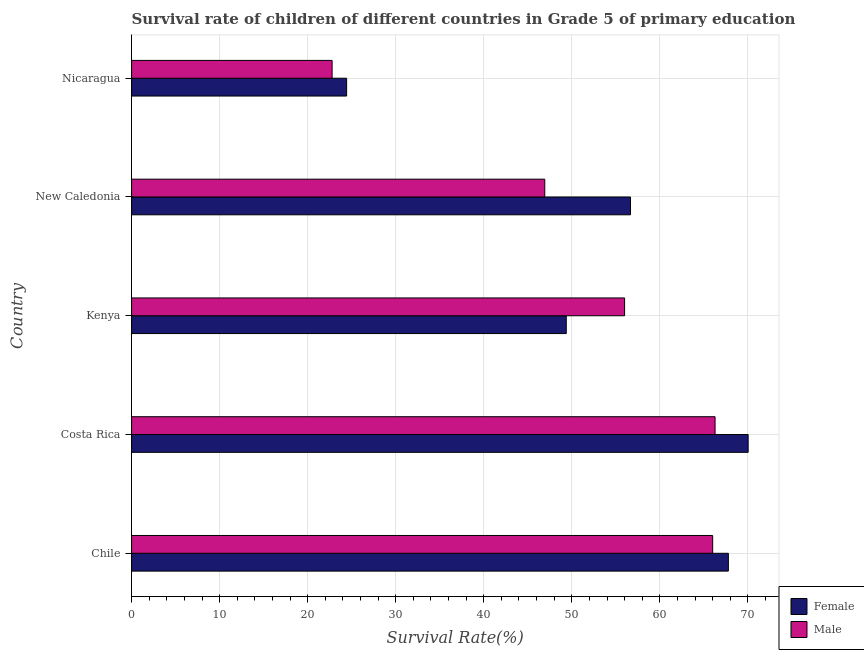How many bars are there on the 2nd tick from the top?
Offer a very short reply. 2. How many bars are there on the 3rd tick from the bottom?
Your answer should be very brief. 2. What is the label of the 1st group of bars from the top?
Your answer should be very brief. Nicaragua. In how many cases, is the number of bars for a given country not equal to the number of legend labels?
Offer a very short reply. 0. What is the survival rate of male students in primary education in Chile?
Make the answer very short. 66. Across all countries, what is the maximum survival rate of female students in primary education?
Make the answer very short. 70.03. Across all countries, what is the minimum survival rate of male students in primary education?
Ensure brevity in your answer.  22.78. In which country was the survival rate of female students in primary education minimum?
Keep it short and to the point. Nicaragua. What is the total survival rate of female students in primary education in the graph?
Provide a short and direct response. 268.29. What is the difference between the survival rate of male students in primary education in Costa Rica and that in New Caledonia?
Your answer should be very brief. 19.34. What is the difference between the survival rate of male students in primary education in Costa Rica and the survival rate of female students in primary education in Nicaragua?
Provide a short and direct response. 41.85. What is the average survival rate of male students in primary education per country?
Make the answer very short. 51.6. What is the difference between the survival rate of male students in primary education and survival rate of female students in primary education in Nicaragua?
Offer a terse response. -1.65. In how many countries, is the survival rate of female students in primary education greater than 66 %?
Ensure brevity in your answer.  2. What is the ratio of the survival rate of male students in primary education in Costa Rica to that in New Caledonia?
Provide a succinct answer. 1.41. Is the survival rate of female students in primary education in Costa Rica less than that in Nicaragua?
Provide a short and direct response. No. Is the difference between the survival rate of male students in primary education in Kenya and New Caledonia greater than the difference between the survival rate of female students in primary education in Kenya and New Caledonia?
Offer a terse response. Yes. What is the difference between the highest and the second highest survival rate of male students in primary education?
Provide a short and direct response. 0.27. What is the difference between the highest and the lowest survival rate of female students in primary education?
Your answer should be compact. 45.61. In how many countries, is the survival rate of female students in primary education greater than the average survival rate of female students in primary education taken over all countries?
Your answer should be very brief. 3. Is the sum of the survival rate of male students in primary education in Kenya and Nicaragua greater than the maximum survival rate of female students in primary education across all countries?
Ensure brevity in your answer.  Yes. What does the 1st bar from the bottom in Nicaragua represents?
Offer a terse response. Female. Are all the bars in the graph horizontal?
Keep it short and to the point. Yes. How many countries are there in the graph?
Ensure brevity in your answer.  5. What is the difference between two consecutive major ticks on the X-axis?
Give a very brief answer. 10. Does the graph contain any zero values?
Your answer should be compact. No. Does the graph contain grids?
Ensure brevity in your answer.  Yes. How many legend labels are there?
Ensure brevity in your answer.  2. How are the legend labels stacked?
Your answer should be very brief. Vertical. What is the title of the graph?
Provide a succinct answer. Survival rate of children of different countries in Grade 5 of primary education. Does "Passenger Transport Items" appear as one of the legend labels in the graph?
Offer a very short reply. No. What is the label or title of the X-axis?
Give a very brief answer. Survival Rate(%). What is the Survival Rate(%) in Female in Chile?
Your answer should be compact. 67.79. What is the Survival Rate(%) in Male in Chile?
Offer a very short reply. 66. What is the Survival Rate(%) of Female in Costa Rica?
Provide a succinct answer. 70.03. What is the Survival Rate(%) in Male in Costa Rica?
Ensure brevity in your answer.  66.27. What is the Survival Rate(%) in Female in Kenya?
Your response must be concise. 49.37. What is the Survival Rate(%) of Male in Kenya?
Your answer should be compact. 56. What is the Survival Rate(%) in Female in New Caledonia?
Make the answer very short. 56.67. What is the Survival Rate(%) of Male in New Caledonia?
Make the answer very short. 46.93. What is the Survival Rate(%) of Female in Nicaragua?
Ensure brevity in your answer.  24.43. What is the Survival Rate(%) in Male in Nicaragua?
Give a very brief answer. 22.78. Across all countries, what is the maximum Survival Rate(%) in Female?
Make the answer very short. 70.03. Across all countries, what is the maximum Survival Rate(%) in Male?
Offer a very short reply. 66.27. Across all countries, what is the minimum Survival Rate(%) in Female?
Your answer should be compact. 24.43. Across all countries, what is the minimum Survival Rate(%) in Male?
Your answer should be compact. 22.78. What is the total Survival Rate(%) of Female in the graph?
Provide a short and direct response. 268.29. What is the total Survival Rate(%) of Male in the graph?
Keep it short and to the point. 257.98. What is the difference between the Survival Rate(%) in Female in Chile and that in Costa Rica?
Provide a succinct answer. -2.25. What is the difference between the Survival Rate(%) of Male in Chile and that in Costa Rica?
Your response must be concise. -0.27. What is the difference between the Survival Rate(%) of Female in Chile and that in Kenya?
Your answer should be very brief. 18.41. What is the difference between the Survival Rate(%) in Male in Chile and that in Kenya?
Give a very brief answer. 10. What is the difference between the Survival Rate(%) in Female in Chile and that in New Caledonia?
Your response must be concise. 11.12. What is the difference between the Survival Rate(%) in Male in Chile and that in New Caledonia?
Keep it short and to the point. 19.07. What is the difference between the Survival Rate(%) in Female in Chile and that in Nicaragua?
Offer a very short reply. 43.36. What is the difference between the Survival Rate(%) of Male in Chile and that in Nicaragua?
Your response must be concise. 43.22. What is the difference between the Survival Rate(%) of Female in Costa Rica and that in Kenya?
Your answer should be compact. 20.66. What is the difference between the Survival Rate(%) of Male in Costa Rica and that in Kenya?
Your answer should be compact. 10.27. What is the difference between the Survival Rate(%) of Female in Costa Rica and that in New Caledonia?
Your response must be concise. 13.36. What is the difference between the Survival Rate(%) in Male in Costa Rica and that in New Caledonia?
Your answer should be compact. 19.34. What is the difference between the Survival Rate(%) in Female in Costa Rica and that in Nicaragua?
Your response must be concise. 45.61. What is the difference between the Survival Rate(%) of Male in Costa Rica and that in Nicaragua?
Make the answer very short. 43.5. What is the difference between the Survival Rate(%) in Female in Kenya and that in New Caledonia?
Provide a short and direct response. -7.3. What is the difference between the Survival Rate(%) of Male in Kenya and that in New Caledonia?
Provide a short and direct response. 9.07. What is the difference between the Survival Rate(%) in Female in Kenya and that in Nicaragua?
Ensure brevity in your answer.  24.95. What is the difference between the Survival Rate(%) in Male in Kenya and that in Nicaragua?
Keep it short and to the point. 33.22. What is the difference between the Survival Rate(%) in Female in New Caledonia and that in Nicaragua?
Your response must be concise. 32.24. What is the difference between the Survival Rate(%) in Male in New Caledonia and that in Nicaragua?
Your answer should be very brief. 24.15. What is the difference between the Survival Rate(%) of Female in Chile and the Survival Rate(%) of Male in Costa Rica?
Keep it short and to the point. 1.51. What is the difference between the Survival Rate(%) in Female in Chile and the Survival Rate(%) in Male in Kenya?
Provide a short and direct response. 11.79. What is the difference between the Survival Rate(%) of Female in Chile and the Survival Rate(%) of Male in New Caledonia?
Keep it short and to the point. 20.86. What is the difference between the Survival Rate(%) of Female in Chile and the Survival Rate(%) of Male in Nicaragua?
Offer a terse response. 45.01. What is the difference between the Survival Rate(%) of Female in Costa Rica and the Survival Rate(%) of Male in Kenya?
Ensure brevity in your answer.  14.03. What is the difference between the Survival Rate(%) of Female in Costa Rica and the Survival Rate(%) of Male in New Caledonia?
Your answer should be compact. 23.1. What is the difference between the Survival Rate(%) in Female in Costa Rica and the Survival Rate(%) in Male in Nicaragua?
Make the answer very short. 47.26. What is the difference between the Survival Rate(%) in Female in Kenya and the Survival Rate(%) in Male in New Caledonia?
Your response must be concise. 2.44. What is the difference between the Survival Rate(%) of Female in Kenya and the Survival Rate(%) of Male in Nicaragua?
Your answer should be compact. 26.6. What is the difference between the Survival Rate(%) of Female in New Caledonia and the Survival Rate(%) of Male in Nicaragua?
Keep it short and to the point. 33.89. What is the average Survival Rate(%) of Female per country?
Keep it short and to the point. 53.66. What is the average Survival Rate(%) of Male per country?
Your answer should be compact. 51.6. What is the difference between the Survival Rate(%) in Female and Survival Rate(%) in Male in Chile?
Keep it short and to the point. 1.79. What is the difference between the Survival Rate(%) in Female and Survival Rate(%) in Male in Costa Rica?
Keep it short and to the point. 3.76. What is the difference between the Survival Rate(%) in Female and Survival Rate(%) in Male in Kenya?
Ensure brevity in your answer.  -6.63. What is the difference between the Survival Rate(%) of Female and Survival Rate(%) of Male in New Caledonia?
Offer a very short reply. 9.74. What is the difference between the Survival Rate(%) of Female and Survival Rate(%) of Male in Nicaragua?
Your response must be concise. 1.65. What is the ratio of the Survival Rate(%) in Female in Chile to that in Costa Rica?
Your answer should be compact. 0.97. What is the ratio of the Survival Rate(%) in Male in Chile to that in Costa Rica?
Make the answer very short. 1. What is the ratio of the Survival Rate(%) of Female in Chile to that in Kenya?
Give a very brief answer. 1.37. What is the ratio of the Survival Rate(%) in Male in Chile to that in Kenya?
Ensure brevity in your answer.  1.18. What is the ratio of the Survival Rate(%) in Female in Chile to that in New Caledonia?
Your answer should be very brief. 1.2. What is the ratio of the Survival Rate(%) in Male in Chile to that in New Caledonia?
Your answer should be compact. 1.41. What is the ratio of the Survival Rate(%) in Female in Chile to that in Nicaragua?
Your response must be concise. 2.78. What is the ratio of the Survival Rate(%) of Male in Chile to that in Nicaragua?
Provide a short and direct response. 2.9. What is the ratio of the Survival Rate(%) in Female in Costa Rica to that in Kenya?
Your response must be concise. 1.42. What is the ratio of the Survival Rate(%) of Male in Costa Rica to that in Kenya?
Keep it short and to the point. 1.18. What is the ratio of the Survival Rate(%) in Female in Costa Rica to that in New Caledonia?
Your response must be concise. 1.24. What is the ratio of the Survival Rate(%) in Male in Costa Rica to that in New Caledonia?
Give a very brief answer. 1.41. What is the ratio of the Survival Rate(%) in Female in Costa Rica to that in Nicaragua?
Make the answer very short. 2.87. What is the ratio of the Survival Rate(%) of Male in Costa Rica to that in Nicaragua?
Give a very brief answer. 2.91. What is the ratio of the Survival Rate(%) in Female in Kenya to that in New Caledonia?
Offer a very short reply. 0.87. What is the ratio of the Survival Rate(%) of Male in Kenya to that in New Caledonia?
Offer a terse response. 1.19. What is the ratio of the Survival Rate(%) in Female in Kenya to that in Nicaragua?
Keep it short and to the point. 2.02. What is the ratio of the Survival Rate(%) of Male in Kenya to that in Nicaragua?
Ensure brevity in your answer.  2.46. What is the ratio of the Survival Rate(%) in Female in New Caledonia to that in Nicaragua?
Your answer should be very brief. 2.32. What is the ratio of the Survival Rate(%) of Male in New Caledonia to that in Nicaragua?
Make the answer very short. 2.06. What is the difference between the highest and the second highest Survival Rate(%) in Female?
Make the answer very short. 2.25. What is the difference between the highest and the second highest Survival Rate(%) in Male?
Keep it short and to the point. 0.27. What is the difference between the highest and the lowest Survival Rate(%) of Female?
Provide a succinct answer. 45.61. What is the difference between the highest and the lowest Survival Rate(%) of Male?
Your answer should be compact. 43.5. 